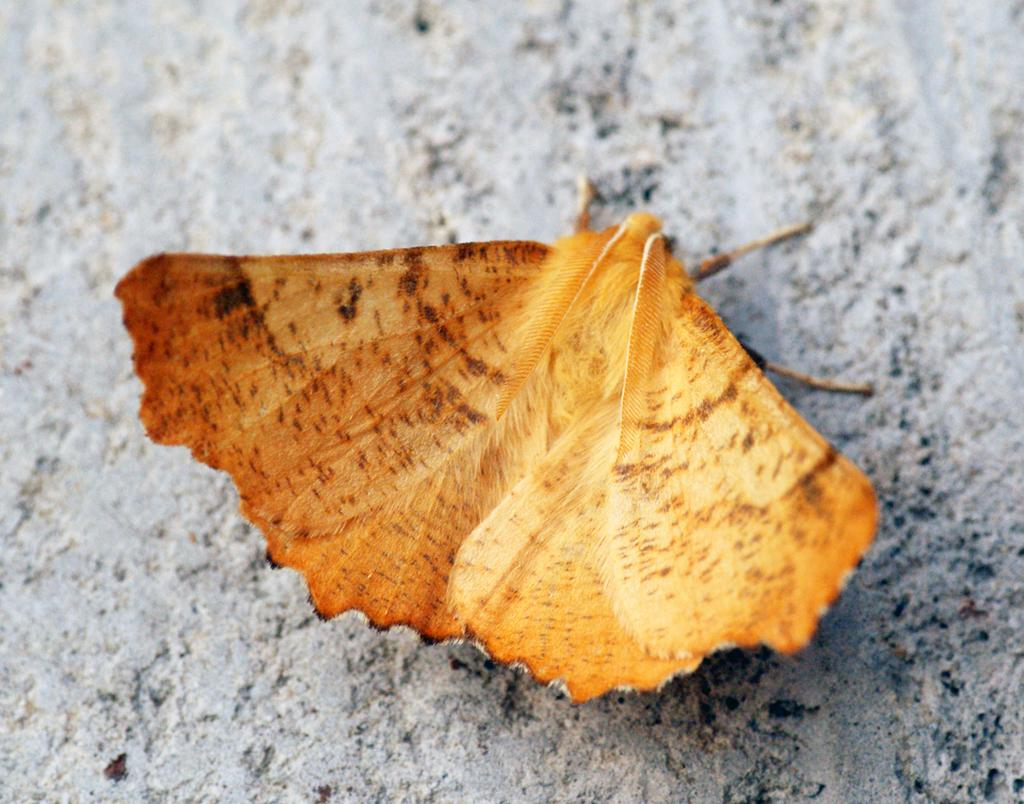What can be seen on the wall in the picture? There is a moth on the wall in the picture. Can you describe the moth's physical features? The moth has wings and legs. What type of sack can be seen hanging from the moth's legs in the image? There is no sack present in the image, and the moth's legs are not holding any object. 